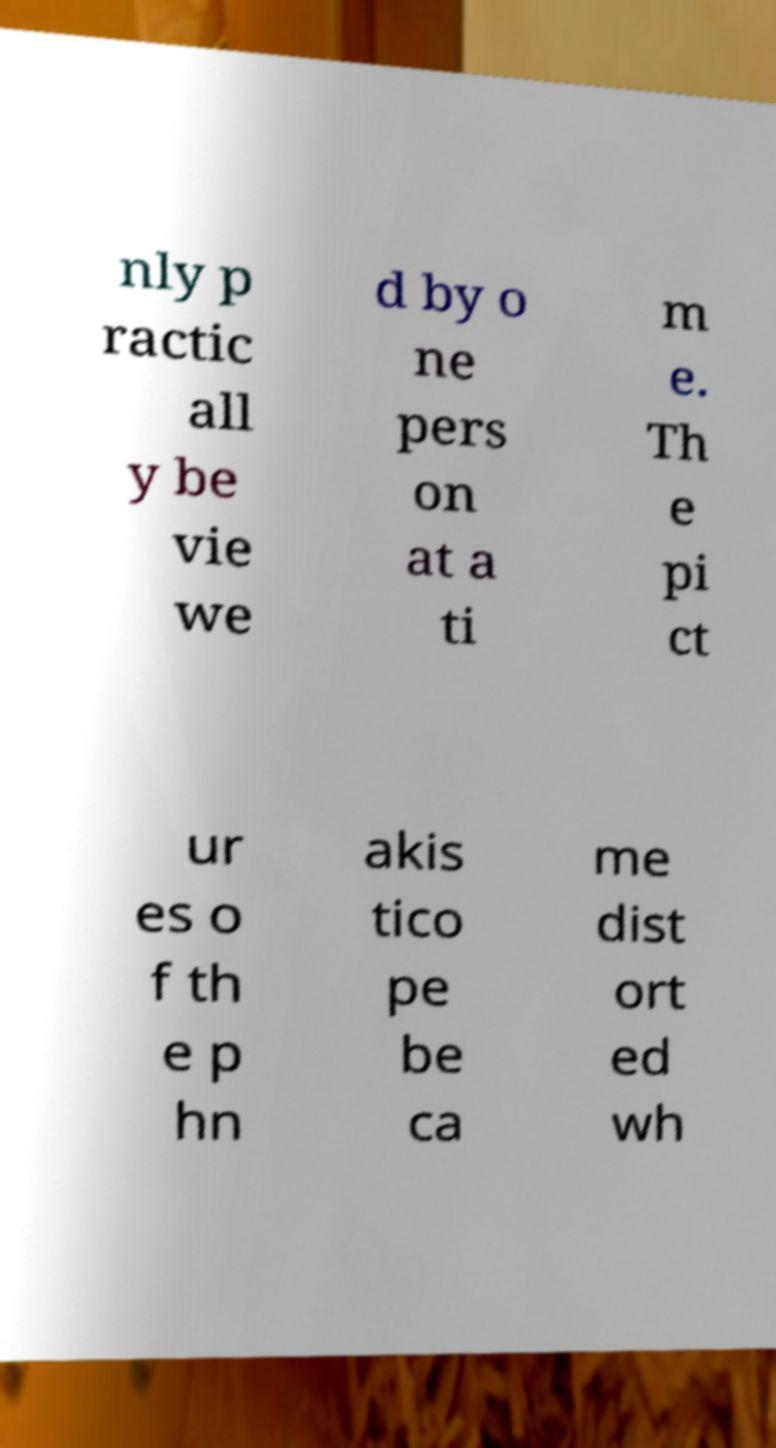Can you read and provide the text displayed in the image?This photo seems to have some interesting text. Can you extract and type it out for me? nly p ractic all y be vie we d by o ne pers on at a ti m e. Th e pi ct ur es o f th e p hn akis tico pe be ca me dist ort ed wh 